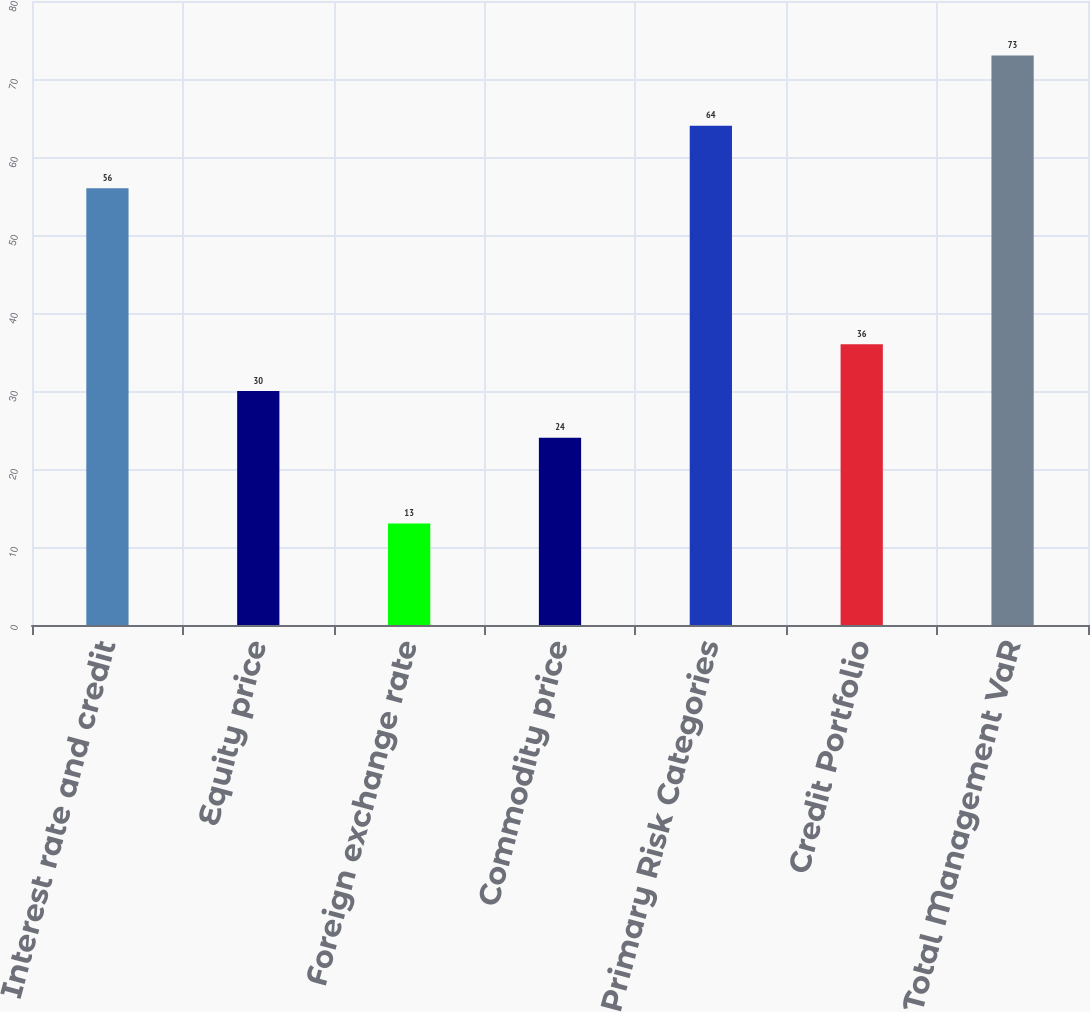Convert chart. <chart><loc_0><loc_0><loc_500><loc_500><bar_chart><fcel>Interest rate and credit<fcel>Equity price<fcel>Foreign exchange rate<fcel>Commodity price<fcel>Primary Risk Categories<fcel>Credit Portfolio<fcel>Total Management VaR<nl><fcel>56<fcel>30<fcel>13<fcel>24<fcel>64<fcel>36<fcel>73<nl></chart> 